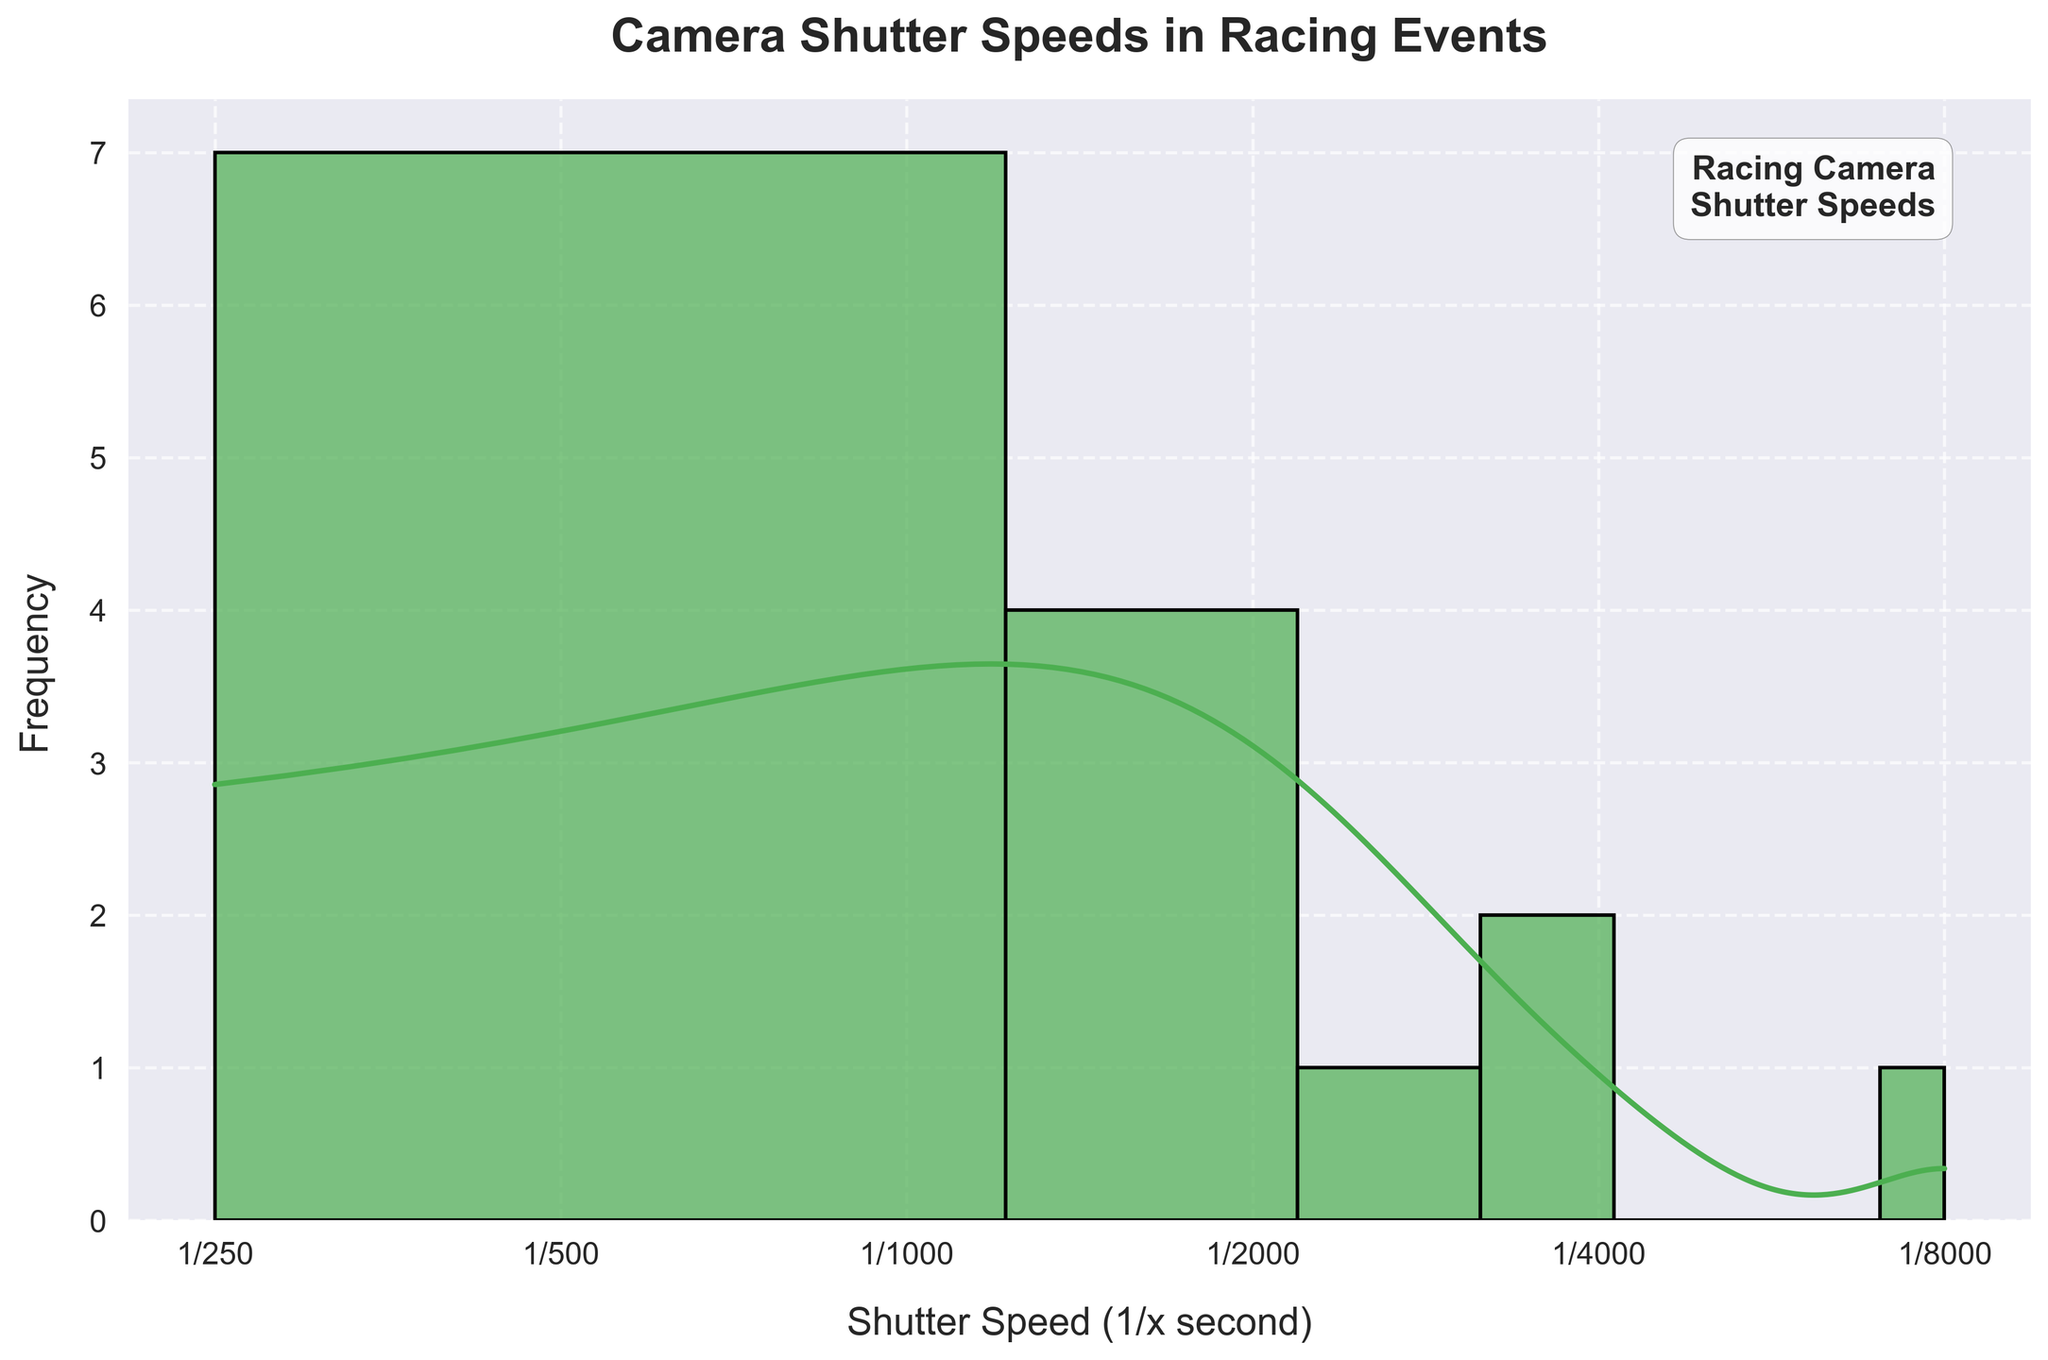What is the title of the histogram? The title of the histogram is usually found at the top of the figure. In this case, it reads "Camera Shutter Speeds in Racing Events".
Answer: Camera Shutter Speeds in Racing Events How is the x-axis labeled and scaled? The label on the x-axis is typically written below the axis. It is labeled "Shutter Speed (1/x second)" and is scaled logarithmically with tick marks at specific shutter speeds: 1/250, 1/500, 1/1000, 1/2000, 1/4000, and 1/8000 seconds.
Answer: Shutter Speed (1/x second), log scale What color is used to represent the histogram bars? The color of the histogram bars can be seen visually, and in this figure, the bars are colored '#'4CAF50', which is a shade of green.
Answer: Green (#4CAF50) How many different shutter speeds are shown in the histogram? Count the number of unique shutter speed values indicated on the x-axis. The unique values are: 1/250, 1/500, 1/640, 1/800, 1/1000, 1/1250, 1/1500, 1/1600, 1/2000, 1/2500, 1/3200, 1/4000, and 1/8000. There are 13 unique shutter speeds.
Answer: 13 What is the most common shutter speed used in racing events based on the histogram? Identify the highest bar in the histogram, which represents the most frequent shutter speed. The highest bar appears at the 1/1000 shutter speed mark.
Answer: 1/1000 Which racing event has the fastest shutter speed based on this data? Compare the shutter speeds used in different events and find the fastest one. The fastest shutter speed used is 1/8000, which is from the Drag Racing NHRA Finals.
Answer: Drag Racing NHRA Finals What can you say about the range of the shutter speeds used? The range of the shutter speeds is determined by the difference between the highest and lowest values on the x-axis. The lowest value is 1/250 and the highest is 1/8000. So, the range is from 1/250 to 1/8000 seconds.
Answer: 1/250 to 1/8000 seconds What is the general trend observed in the density curve (KDE) of the histogram? The density curve (KDE) gives an idea of the probability distribution of the shutter speeds. The curve shows a peak around 1/1000 shutter speed, indicating it is the most common, and then decreases as the shutter speed increases or decreases from this point.
Answer: Peaks around 1/1000 and gradually decreases Which range of shutter speeds appears to be the least common? Look for the regions in the histogram where the bars are smallest or absent. The least common shutter speeds are at the extremes: 1/250 and 1/640 have very small or no bars.
Answer: 1/250 and 1/640 